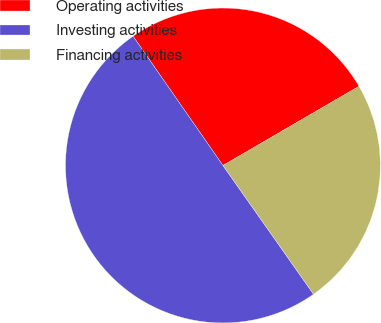<chart> <loc_0><loc_0><loc_500><loc_500><pie_chart><fcel>Operating activities<fcel>Investing activities<fcel>Financing activities<nl><fcel>26.28%<fcel>50.09%<fcel>23.63%<nl></chart> 